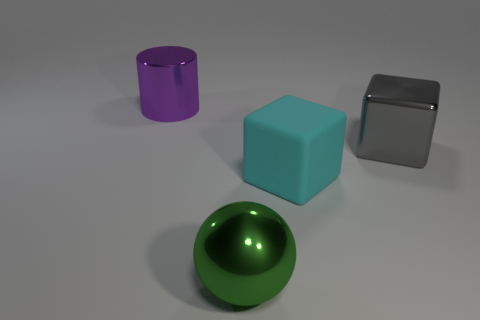Is there any other thing that has the same shape as the big cyan thing?
Offer a very short reply. Yes. There is a thing that is on the left side of the metal ball; what material is it?
Give a very brief answer. Metal. Does the thing behind the big gray shiny block have the same material as the big cyan thing?
Offer a terse response. No. What number of objects are big yellow cylinders or blocks behind the large cyan matte thing?
Offer a terse response. 1. What is the size of the metallic object that is the same shape as the large rubber object?
Provide a succinct answer. Large. Are there any shiny blocks behind the large cyan block?
Provide a succinct answer. Yes. Is there another rubber object that has the same shape as the green object?
Your response must be concise. No. What number of other objects are the same color as the big rubber object?
Your answer should be very brief. 0. There is a big shiny object that is in front of the cyan rubber thing that is to the right of the large green metal thing to the left of the big gray metal cube; what color is it?
Your response must be concise. Green. Are there an equal number of big green spheres that are behind the purple metal cylinder and large purple cubes?
Keep it short and to the point. Yes. 